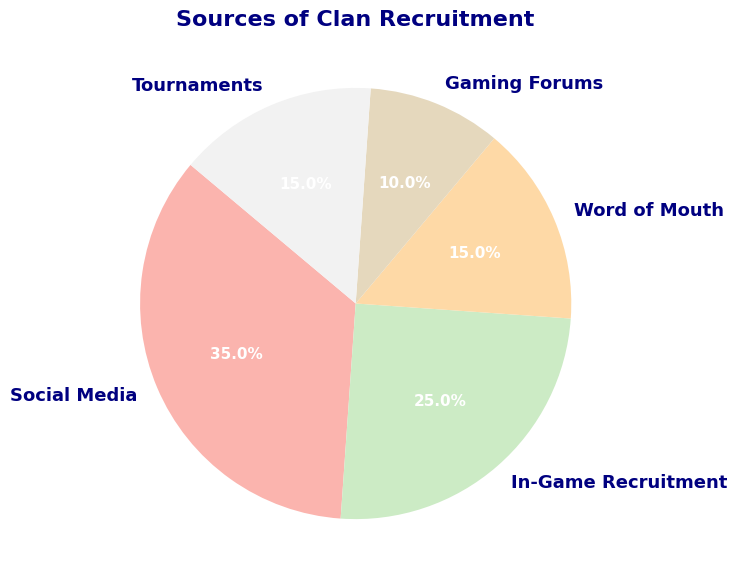What percentage of clan recruitment comes from Tournaments? The slice of the pie chart labeled 'Tournaments' shows its contribution. The corresponding percentage is directly visible.
Answer: 15% Which recruitment source has the smallest percentage? By observing the pie chart, find and compare the size of the slices. The slice labeled 'Gaming Forums' is the smallest.
Answer: Gaming Forums How much larger is the percentage of Social Media recruitment compared to Word of Mouth recruitment? Subtract the percentage of Word of Mouth recruitment (15%) from the percentage of Social Media (35%). 35 - 15 = 20
Answer: 20% What is the total percentage for Word of Mouth and Tournaments combined? Add the percentages of Word of Mouth (15%) and Tournaments (15%). 15 + 15 = 30
Answer: 30% Is the percentage of In-Game Recruitment greater than the percentage of Gaming Forums? Compare the slices labeled 'In-Game Recruitment' and 'Gaming Forums'. In-Game Recruitment (25%) is greater than Gaming Forums (10%).
Answer: Yes What are the major recruitment sources, constituting more than 20%? Identify all slices with percentages greater than 20%. Social Media (35%) and In-Game Recruitment (25%) fit this criterion.
Answer: Social Media, In-Game Recruitment What is the combined percentage of recruitment from Social Media, In-Game Recruitment, and Gaming Forums? Add the percentages of Social Media (35%), In-Game Recruitment (25%), and Gaming Forums (10%). 35 + 25 + 10 = 70
Answer: 70% Which recruitment source has a percentage equivalent to that of Word of Mouth? Find the slice with the same percentage as Word of Mouth (15%). The equivalent source is Tournaments.
Answer: Tournaments If another recruitment source had 8% and was added to the pie, what would be the total percentage? The current total is 100%. Adding another 8% would result in 100 + 8.
Answer: 108% What percentage is missing if the pie chart is supposed to total 100% and only Social Media and In-Game Recruitment percentages are known? Subtract the sum of Social Media (35%) and In-Game Recruitment (25%) from 100%. 100 - (35 + 25) = 40
Answer: 40% 